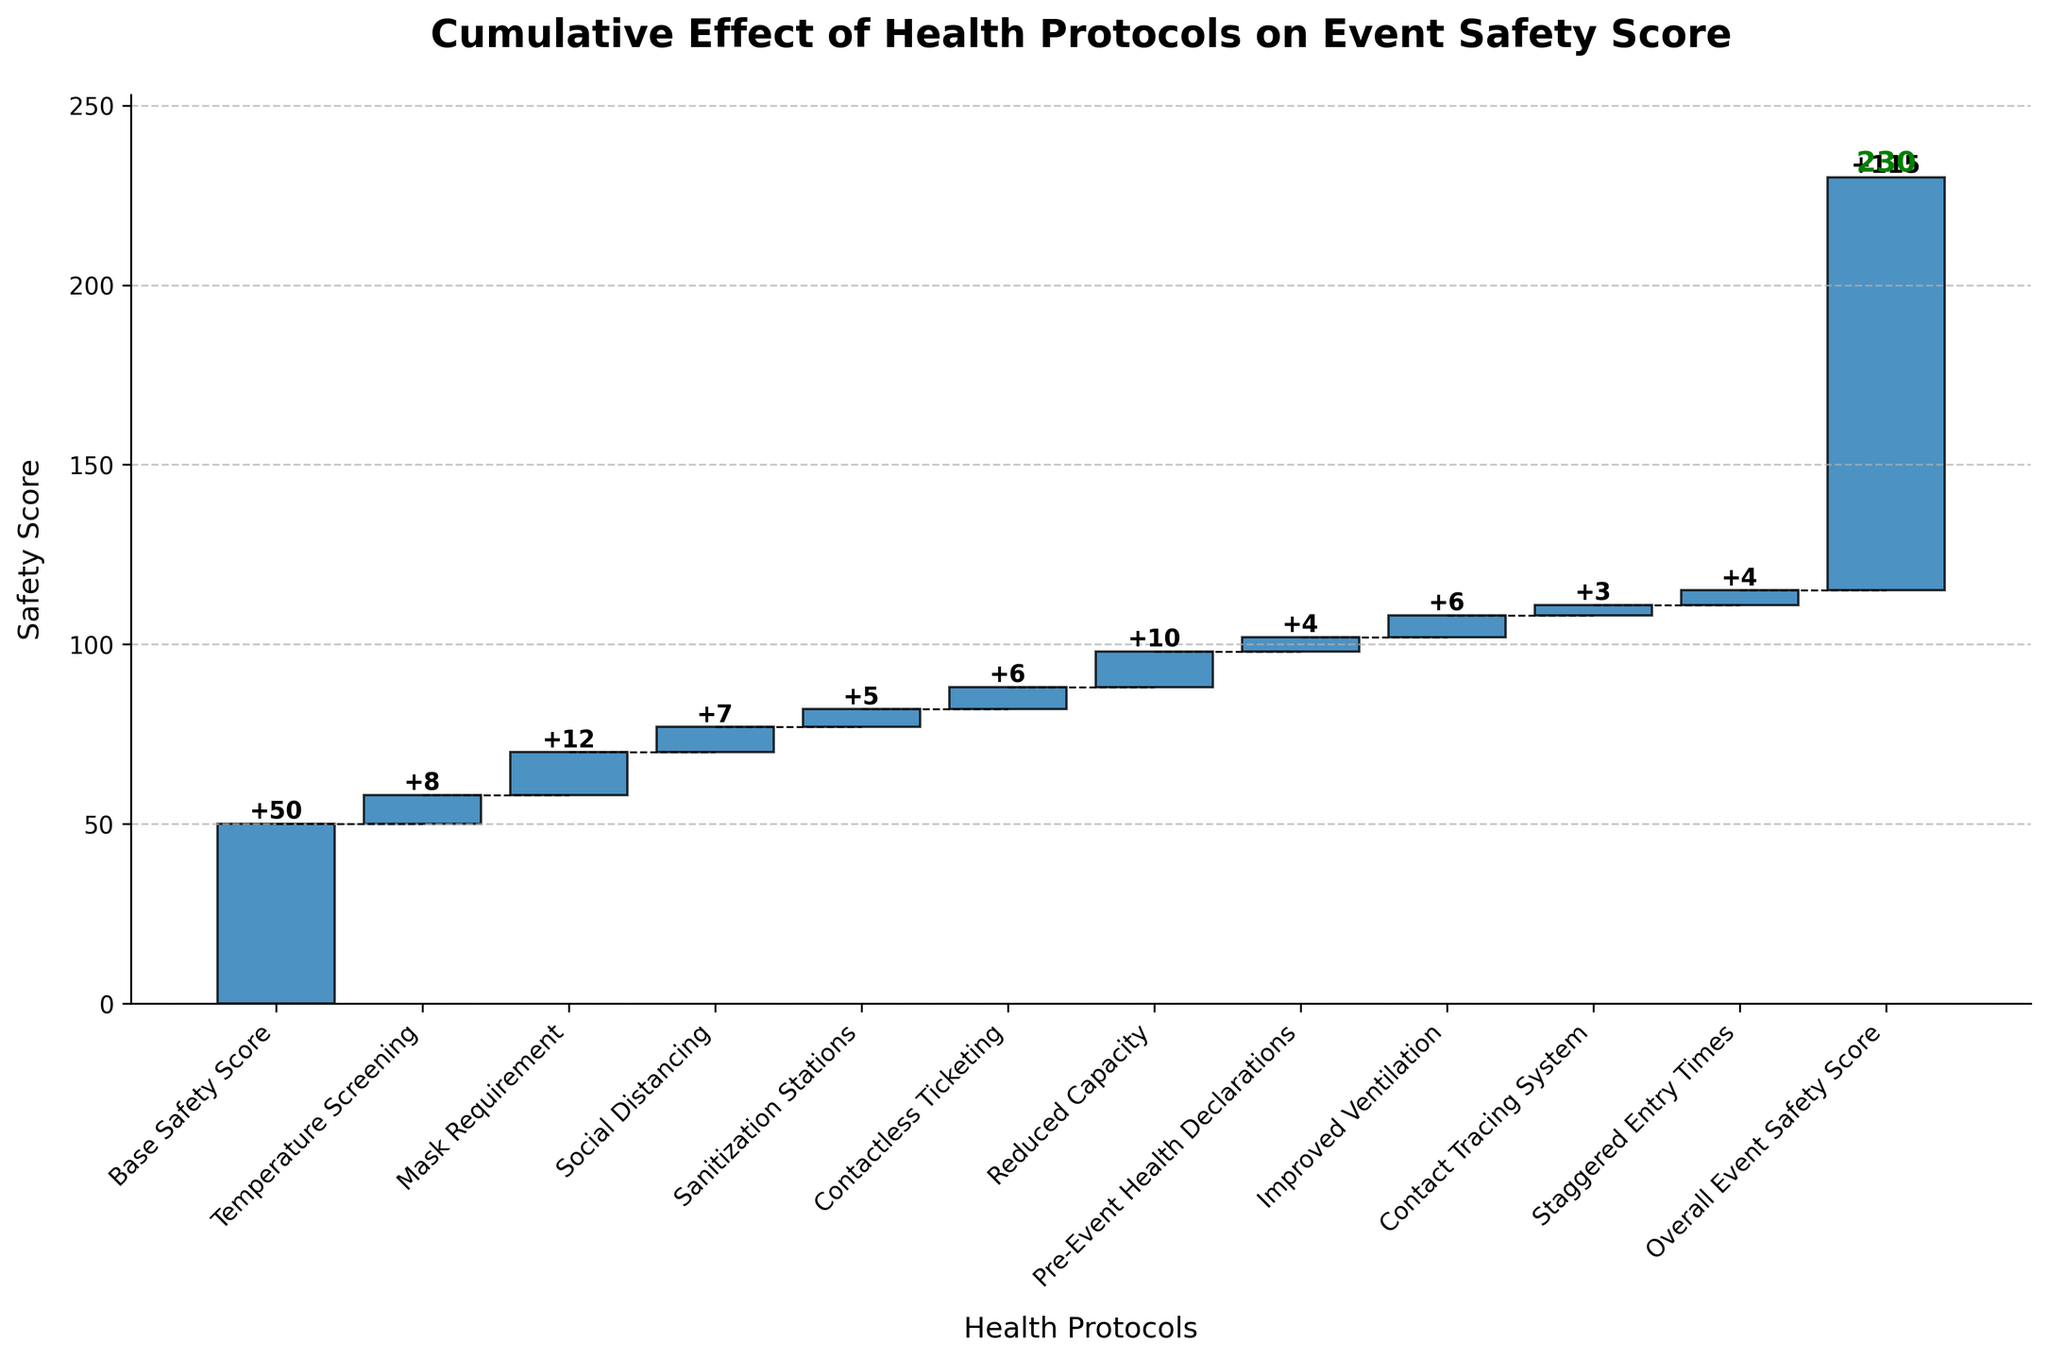What is the title of the Waterfall Chart? The title of the chart is positioned at the top of the figure. It is meant to draw attention to the overall theme of the chart.
Answer: Cumulative Effect of Health Protocols on Event Safety Score Which health protocol contributed the highest increase in the event safety score? By examining the values associated with each health protocol in ascending order, we can identify which value is the highest.
Answer: Mask Requirement What is the overall event safety score displayed at the end of the chart? The overall safety score is the final cumulative value in the Waterfall Chart. It is often highlighted in bold or a different color.
Answer: 115 How much does Temperature Screening increase the safety score? Look at the value associated with Temperature Screening in the figure.
Answer: 8 What cumulative safety score is achieved after implementing Social Distancing? To find the cumulative score after Social Distancing, sum the Base Safety Score and all subsequent values up to and including Social Distancing. 50 (Base Safety Score) + 8 (Temperature Screening) + 12 (Mask Requirement) + 7 (Social Distancing).
Answer: 77 If we added up the contributions of Sanitization Stations and Contactless Ticketing, what would the total be? Add the individual values attributed to Sanitization Stations and Contactless Ticketing. 5 (Sanitization Stations) + 6 (Contactless Ticketing).
Answer: 11 Which health protocol resulted in the smallest increase in the safety score? Compare all the individual values and identify the smallest positive number.
Answer: Contact Tracing System What's the cumulative effect of the safety protocols before Reduced Capacity? Calculate the cumulative sum of all values up to but not including Reduced Capacity. 50 (Base Safety Score) + 8 (Temperature Screening) + 12 (Mask Requirement) + 7 (Social Distancing) + 5 (Sanitization Stations) + 6 (Contactless Ticketing).
Answer: 88 What is the difference in safety score contributions between Mask Requirement and Improved Ventilation? Subtract the value of Improved Ventilation from the value of Mask Requirement. 12 (Mask Requirement) - 6 (Improved Ventilation).
Answer: 6 By how much did Pre-Event Health Declarations raise the safety score? Look at the value associated with Pre-Event Health Declarations in the figure.
Answer: 4 